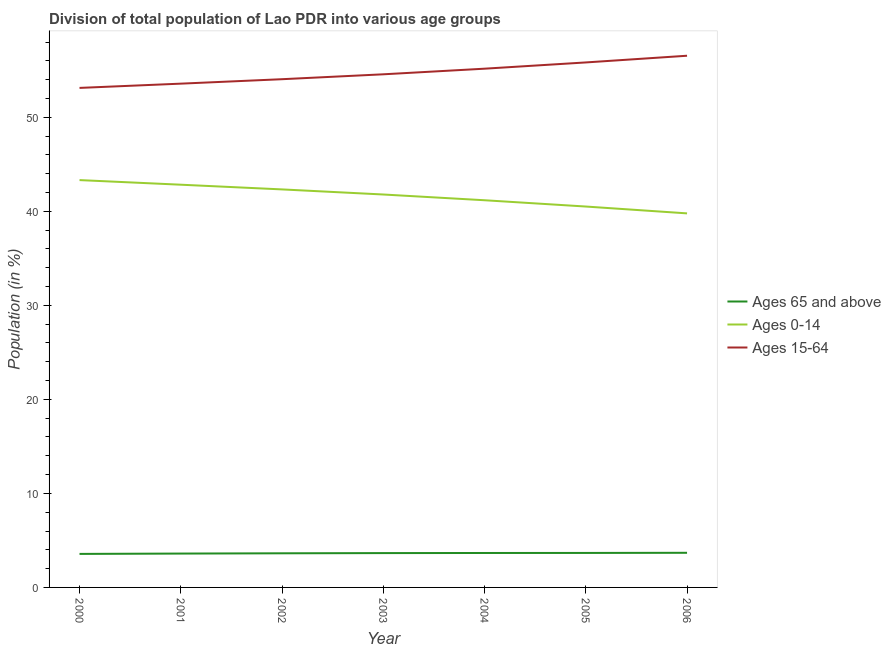What is the percentage of population within the age-group of 65 and above in 2005?
Your response must be concise. 3.67. Across all years, what is the maximum percentage of population within the age-group 0-14?
Your answer should be very brief. 43.32. Across all years, what is the minimum percentage of population within the age-group 0-14?
Provide a succinct answer. 39.78. In which year was the percentage of population within the age-group 0-14 maximum?
Give a very brief answer. 2000. In which year was the percentage of population within the age-group of 65 and above minimum?
Keep it short and to the point. 2000. What is the total percentage of population within the age-group of 65 and above in the graph?
Your response must be concise. 25.46. What is the difference between the percentage of population within the age-group 15-64 in 2000 and that in 2002?
Keep it short and to the point. -0.93. What is the difference between the percentage of population within the age-group of 65 and above in 2004 and the percentage of population within the age-group 15-64 in 2001?
Offer a very short reply. -49.91. What is the average percentage of population within the age-group of 65 and above per year?
Your response must be concise. 3.64. In the year 2001, what is the difference between the percentage of population within the age-group of 65 and above and percentage of population within the age-group 0-14?
Your response must be concise. -39.23. What is the ratio of the percentage of population within the age-group 15-64 in 2002 to that in 2003?
Your answer should be compact. 0.99. Is the difference between the percentage of population within the age-group of 65 and above in 2001 and 2003 greater than the difference between the percentage of population within the age-group 0-14 in 2001 and 2003?
Your response must be concise. No. What is the difference between the highest and the second highest percentage of population within the age-group 15-64?
Provide a succinct answer. 0.71. What is the difference between the highest and the lowest percentage of population within the age-group 15-64?
Your answer should be compact. 3.42. Is the sum of the percentage of population within the age-group 0-14 in 2004 and 2006 greater than the maximum percentage of population within the age-group of 65 and above across all years?
Provide a succinct answer. Yes. Does the percentage of population within the age-group 15-64 monotonically increase over the years?
Ensure brevity in your answer.  Yes. Is the percentage of population within the age-group 0-14 strictly greater than the percentage of population within the age-group 15-64 over the years?
Make the answer very short. No. How many lines are there?
Offer a very short reply. 3. Are the values on the major ticks of Y-axis written in scientific E-notation?
Offer a very short reply. No. Does the graph contain any zero values?
Your response must be concise. No. How many legend labels are there?
Provide a short and direct response. 3. What is the title of the graph?
Provide a short and direct response. Division of total population of Lao PDR into various age groups
. Does "Self-employed" appear as one of the legend labels in the graph?
Ensure brevity in your answer.  No. What is the label or title of the Y-axis?
Give a very brief answer. Population (in %). What is the Population (in %) in Ages 65 and above in 2000?
Offer a terse response. 3.56. What is the Population (in %) of Ages 0-14 in 2000?
Your answer should be compact. 43.32. What is the Population (in %) of Ages 15-64 in 2000?
Your answer should be very brief. 53.12. What is the Population (in %) of Ages 65 and above in 2001?
Give a very brief answer. 3.6. What is the Population (in %) in Ages 0-14 in 2001?
Give a very brief answer. 42.83. What is the Population (in %) of Ages 15-64 in 2001?
Give a very brief answer. 53.57. What is the Population (in %) in Ages 65 and above in 2002?
Provide a succinct answer. 3.63. What is the Population (in %) in Ages 0-14 in 2002?
Offer a very short reply. 42.33. What is the Population (in %) in Ages 15-64 in 2002?
Keep it short and to the point. 54.04. What is the Population (in %) of Ages 65 and above in 2003?
Keep it short and to the point. 3.65. What is the Population (in %) of Ages 0-14 in 2003?
Provide a short and direct response. 41.78. What is the Population (in %) in Ages 15-64 in 2003?
Provide a short and direct response. 54.57. What is the Population (in %) of Ages 65 and above in 2004?
Offer a terse response. 3.66. What is the Population (in %) of Ages 0-14 in 2004?
Make the answer very short. 41.17. What is the Population (in %) of Ages 15-64 in 2004?
Provide a short and direct response. 55.16. What is the Population (in %) in Ages 65 and above in 2005?
Your answer should be very brief. 3.67. What is the Population (in %) in Ages 0-14 in 2005?
Offer a very short reply. 40.5. What is the Population (in %) of Ages 15-64 in 2005?
Your answer should be compact. 55.83. What is the Population (in %) in Ages 65 and above in 2006?
Your response must be concise. 3.68. What is the Population (in %) of Ages 0-14 in 2006?
Your answer should be very brief. 39.78. What is the Population (in %) of Ages 15-64 in 2006?
Make the answer very short. 56.54. Across all years, what is the maximum Population (in %) of Ages 65 and above?
Ensure brevity in your answer.  3.68. Across all years, what is the maximum Population (in %) in Ages 0-14?
Give a very brief answer. 43.32. Across all years, what is the maximum Population (in %) in Ages 15-64?
Provide a short and direct response. 56.54. Across all years, what is the minimum Population (in %) of Ages 65 and above?
Keep it short and to the point. 3.56. Across all years, what is the minimum Population (in %) of Ages 0-14?
Offer a very short reply. 39.78. Across all years, what is the minimum Population (in %) in Ages 15-64?
Your answer should be compact. 53.12. What is the total Population (in %) in Ages 65 and above in the graph?
Provide a short and direct response. 25.46. What is the total Population (in %) of Ages 0-14 in the graph?
Provide a short and direct response. 291.71. What is the total Population (in %) of Ages 15-64 in the graph?
Keep it short and to the point. 382.83. What is the difference between the Population (in %) in Ages 65 and above in 2000 and that in 2001?
Make the answer very short. -0.04. What is the difference between the Population (in %) in Ages 0-14 in 2000 and that in 2001?
Make the answer very short. 0.49. What is the difference between the Population (in %) of Ages 15-64 in 2000 and that in 2001?
Your answer should be very brief. -0.45. What is the difference between the Population (in %) of Ages 65 and above in 2000 and that in 2002?
Your response must be concise. -0.06. What is the difference between the Population (in %) of Ages 15-64 in 2000 and that in 2002?
Make the answer very short. -0.93. What is the difference between the Population (in %) of Ages 65 and above in 2000 and that in 2003?
Your answer should be very brief. -0.09. What is the difference between the Population (in %) of Ages 0-14 in 2000 and that in 2003?
Offer a very short reply. 1.53. What is the difference between the Population (in %) in Ages 15-64 in 2000 and that in 2003?
Make the answer very short. -1.45. What is the difference between the Population (in %) in Ages 65 and above in 2000 and that in 2004?
Offer a terse response. -0.1. What is the difference between the Population (in %) in Ages 0-14 in 2000 and that in 2004?
Offer a terse response. 2.14. What is the difference between the Population (in %) of Ages 15-64 in 2000 and that in 2004?
Your response must be concise. -2.04. What is the difference between the Population (in %) in Ages 65 and above in 2000 and that in 2005?
Provide a short and direct response. -0.1. What is the difference between the Population (in %) of Ages 0-14 in 2000 and that in 2005?
Your answer should be very brief. 2.81. What is the difference between the Population (in %) in Ages 15-64 in 2000 and that in 2005?
Provide a succinct answer. -2.71. What is the difference between the Population (in %) of Ages 65 and above in 2000 and that in 2006?
Provide a succinct answer. -0.12. What is the difference between the Population (in %) in Ages 0-14 in 2000 and that in 2006?
Ensure brevity in your answer.  3.54. What is the difference between the Population (in %) of Ages 15-64 in 2000 and that in 2006?
Make the answer very short. -3.42. What is the difference between the Population (in %) of Ages 65 and above in 2001 and that in 2002?
Provide a short and direct response. -0.03. What is the difference between the Population (in %) in Ages 0-14 in 2001 and that in 2002?
Your answer should be very brief. 0.5. What is the difference between the Population (in %) in Ages 15-64 in 2001 and that in 2002?
Your response must be concise. -0.47. What is the difference between the Population (in %) in Ages 65 and above in 2001 and that in 2003?
Offer a very short reply. -0.05. What is the difference between the Population (in %) of Ages 0-14 in 2001 and that in 2003?
Your response must be concise. 1.04. What is the difference between the Population (in %) in Ages 15-64 in 2001 and that in 2003?
Give a very brief answer. -0.99. What is the difference between the Population (in %) in Ages 65 and above in 2001 and that in 2004?
Make the answer very short. -0.06. What is the difference between the Population (in %) of Ages 0-14 in 2001 and that in 2004?
Offer a terse response. 1.65. What is the difference between the Population (in %) of Ages 15-64 in 2001 and that in 2004?
Offer a terse response. -1.59. What is the difference between the Population (in %) of Ages 65 and above in 2001 and that in 2005?
Give a very brief answer. -0.07. What is the difference between the Population (in %) of Ages 0-14 in 2001 and that in 2005?
Offer a terse response. 2.32. What is the difference between the Population (in %) in Ages 15-64 in 2001 and that in 2005?
Offer a very short reply. -2.26. What is the difference between the Population (in %) in Ages 65 and above in 2001 and that in 2006?
Your answer should be compact. -0.08. What is the difference between the Population (in %) in Ages 0-14 in 2001 and that in 2006?
Ensure brevity in your answer.  3.05. What is the difference between the Population (in %) in Ages 15-64 in 2001 and that in 2006?
Ensure brevity in your answer.  -2.97. What is the difference between the Population (in %) in Ages 65 and above in 2002 and that in 2003?
Your answer should be compact. -0.02. What is the difference between the Population (in %) of Ages 0-14 in 2002 and that in 2003?
Offer a terse response. 0.54. What is the difference between the Population (in %) of Ages 15-64 in 2002 and that in 2003?
Keep it short and to the point. -0.52. What is the difference between the Population (in %) in Ages 65 and above in 2002 and that in 2004?
Keep it short and to the point. -0.03. What is the difference between the Population (in %) in Ages 0-14 in 2002 and that in 2004?
Your answer should be very brief. 1.15. What is the difference between the Population (in %) in Ages 15-64 in 2002 and that in 2004?
Offer a terse response. -1.12. What is the difference between the Population (in %) in Ages 65 and above in 2002 and that in 2005?
Offer a terse response. -0.04. What is the difference between the Population (in %) of Ages 0-14 in 2002 and that in 2005?
Provide a succinct answer. 1.82. What is the difference between the Population (in %) in Ages 15-64 in 2002 and that in 2005?
Make the answer very short. -1.78. What is the difference between the Population (in %) of Ages 65 and above in 2002 and that in 2006?
Your answer should be compact. -0.05. What is the difference between the Population (in %) of Ages 0-14 in 2002 and that in 2006?
Ensure brevity in your answer.  2.55. What is the difference between the Population (in %) in Ages 15-64 in 2002 and that in 2006?
Provide a succinct answer. -2.5. What is the difference between the Population (in %) in Ages 65 and above in 2003 and that in 2004?
Offer a very short reply. -0.01. What is the difference between the Population (in %) of Ages 0-14 in 2003 and that in 2004?
Make the answer very short. 0.61. What is the difference between the Population (in %) in Ages 15-64 in 2003 and that in 2004?
Make the answer very short. -0.6. What is the difference between the Population (in %) in Ages 65 and above in 2003 and that in 2005?
Provide a short and direct response. -0.02. What is the difference between the Population (in %) in Ages 0-14 in 2003 and that in 2005?
Make the answer very short. 1.28. What is the difference between the Population (in %) in Ages 15-64 in 2003 and that in 2005?
Offer a terse response. -1.26. What is the difference between the Population (in %) in Ages 65 and above in 2003 and that in 2006?
Keep it short and to the point. -0.03. What is the difference between the Population (in %) of Ages 0-14 in 2003 and that in 2006?
Your response must be concise. 2.01. What is the difference between the Population (in %) of Ages 15-64 in 2003 and that in 2006?
Offer a very short reply. -1.97. What is the difference between the Population (in %) of Ages 65 and above in 2004 and that in 2005?
Your answer should be compact. -0. What is the difference between the Population (in %) in Ages 0-14 in 2004 and that in 2005?
Ensure brevity in your answer.  0.67. What is the difference between the Population (in %) in Ages 15-64 in 2004 and that in 2005?
Give a very brief answer. -0.66. What is the difference between the Population (in %) of Ages 65 and above in 2004 and that in 2006?
Give a very brief answer. -0.02. What is the difference between the Population (in %) in Ages 0-14 in 2004 and that in 2006?
Provide a succinct answer. 1.4. What is the difference between the Population (in %) in Ages 15-64 in 2004 and that in 2006?
Give a very brief answer. -1.38. What is the difference between the Population (in %) in Ages 65 and above in 2005 and that in 2006?
Provide a succinct answer. -0.01. What is the difference between the Population (in %) of Ages 0-14 in 2005 and that in 2006?
Provide a short and direct response. 0.73. What is the difference between the Population (in %) in Ages 15-64 in 2005 and that in 2006?
Give a very brief answer. -0.71. What is the difference between the Population (in %) in Ages 65 and above in 2000 and the Population (in %) in Ages 0-14 in 2001?
Provide a succinct answer. -39.26. What is the difference between the Population (in %) in Ages 65 and above in 2000 and the Population (in %) in Ages 15-64 in 2001?
Ensure brevity in your answer.  -50.01. What is the difference between the Population (in %) in Ages 0-14 in 2000 and the Population (in %) in Ages 15-64 in 2001?
Keep it short and to the point. -10.26. What is the difference between the Population (in %) in Ages 65 and above in 2000 and the Population (in %) in Ages 0-14 in 2002?
Make the answer very short. -38.76. What is the difference between the Population (in %) in Ages 65 and above in 2000 and the Population (in %) in Ages 15-64 in 2002?
Provide a short and direct response. -50.48. What is the difference between the Population (in %) of Ages 0-14 in 2000 and the Population (in %) of Ages 15-64 in 2002?
Offer a very short reply. -10.73. What is the difference between the Population (in %) of Ages 65 and above in 2000 and the Population (in %) of Ages 0-14 in 2003?
Provide a short and direct response. -38.22. What is the difference between the Population (in %) of Ages 65 and above in 2000 and the Population (in %) of Ages 15-64 in 2003?
Your answer should be compact. -51. What is the difference between the Population (in %) of Ages 0-14 in 2000 and the Population (in %) of Ages 15-64 in 2003?
Keep it short and to the point. -11.25. What is the difference between the Population (in %) in Ages 65 and above in 2000 and the Population (in %) in Ages 0-14 in 2004?
Your answer should be very brief. -37.61. What is the difference between the Population (in %) in Ages 65 and above in 2000 and the Population (in %) in Ages 15-64 in 2004?
Offer a very short reply. -51.6. What is the difference between the Population (in %) of Ages 0-14 in 2000 and the Population (in %) of Ages 15-64 in 2004?
Provide a succinct answer. -11.85. What is the difference between the Population (in %) in Ages 65 and above in 2000 and the Population (in %) in Ages 0-14 in 2005?
Provide a short and direct response. -36.94. What is the difference between the Population (in %) in Ages 65 and above in 2000 and the Population (in %) in Ages 15-64 in 2005?
Your response must be concise. -52.26. What is the difference between the Population (in %) in Ages 0-14 in 2000 and the Population (in %) in Ages 15-64 in 2005?
Your answer should be very brief. -12.51. What is the difference between the Population (in %) of Ages 65 and above in 2000 and the Population (in %) of Ages 0-14 in 2006?
Provide a short and direct response. -36.21. What is the difference between the Population (in %) in Ages 65 and above in 2000 and the Population (in %) in Ages 15-64 in 2006?
Ensure brevity in your answer.  -52.98. What is the difference between the Population (in %) in Ages 0-14 in 2000 and the Population (in %) in Ages 15-64 in 2006?
Your answer should be very brief. -13.22. What is the difference between the Population (in %) of Ages 65 and above in 2001 and the Population (in %) of Ages 0-14 in 2002?
Offer a terse response. -38.72. What is the difference between the Population (in %) in Ages 65 and above in 2001 and the Population (in %) in Ages 15-64 in 2002?
Make the answer very short. -50.44. What is the difference between the Population (in %) in Ages 0-14 in 2001 and the Population (in %) in Ages 15-64 in 2002?
Ensure brevity in your answer.  -11.22. What is the difference between the Population (in %) of Ages 65 and above in 2001 and the Population (in %) of Ages 0-14 in 2003?
Ensure brevity in your answer.  -38.18. What is the difference between the Population (in %) in Ages 65 and above in 2001 and the Population (in %) in Ages 15-64 in 2003?
Keep it short and to the point. -50.96. What is the difference between the Population (in %) in Ages 0-14 in 2001 and the Population (in %) in Ages 15-64 in 2003?
Keep it short and to the point. -11.74. What is the difference between the Population (in %) in Ages 65 and above in 2001 and the Population (in %) in Ages 0-14 in 2004?
Offer a terse response. -37.57. What is the difference between the Population (in %) of Ages 65 and above in 2001 and the Population (in %) of Ages 15-64 in 2004?
Give a very brief answer. -51.56. What is the difference between the Population (in %) in Ages 0-14 in 2001 and the Population (in %) in Ages 15-64 in 2004?
Your response must be concise. -12.34. What is the difference between the Population (in %) in Ages 65 and above in 2001 and the Population (in %) in Ages 0-14 in 2005?
Ensure brevity in your answer.  -36.9. What is the difference between the Population (in %) of Ages 65 and above in 2001 and the Population (in %) of Ages 15-64 in 2005?
Provide a succinct answer. -52.23. What is the difference between the Population (in %) in Ages 0-14 in 2001 and the Population (in %) in Ages 15-64 in 2005?
Make the answer very short. -13. What is the difference between the Population (in %) of Ages 65 and above in 2001 and the Population (in %) of Ages 0-14 in 2006?
Offer a terse response. -36.18. What is the difference between the Population (in %) in Ages 65 and above in 2001 and the Population (in %) in Ages 15-64 in 2006?
Provide a succinct answer. -52.94. What is the difference between the Population (in %) in Ages 0-14 in 2001 and the Population (in %) in Ages 15-64 in 2006?
Provide a succinct answer. -13.71. What is the difference between the Population (in %) of Ages 65 and above in 2002 and the Population (in %) of Ages 0-14 in 2003?
Provide a succinct answer. -38.15. What is the difference between the Population (in %) in Ages 65 and above in 2002 and the Population (in %) in Ages 15-64 in 2003?
Offer a very short reply. -50.94. What is the difference between the Population (in %) of Ages 0-14 in 2002 and the Population (in %) of Ages 15-64 in 2003?
Keep it short and to the point. -12.24. What is the difference between the Population (in %) of Ages 65 and above in 2002 and the Population (in %) of Ages 0-14 in 2004?
Give a very brief answer. -37.54. What is the difference between the Population (in %) of Ages 65 and above in 2002 and the Population (in %) of Ages 15-64 in 2004?
Your response must be concise. -51.53. What is the difference between the Population (in %) in Ages 0-14 in 2002 and the Population (in %) in Ages 15-64 in 2004?
Your answer should be compact. -12.84. What is the difference between the Population (in %) in Ages 65 and above in 2002 and the Population (in %) in Ages 0-14 in 2005?
Give a very brief answer. -36.88. What is the difference between the Population (in %) of Ages 65 and above in 2002 and the Population (in %) of Ages 15-64 in 2005?
Your response must be concise. -52.2. What is the difference between the Population (in %) of Ages 0-14 in 2002 and the Population (in %) of Ages 15-64 in 2005?
Provide a succinct answer. -13.5. What is the difference between the Population (in %) of Ages 65 and above in 2002 and the Population (in %) of Ages 0-14 in 2006?
Your answer should be very brief. -36.15. What is the difference between the Population (in %) in Ages 65 and above in 2002 and the Population (in %) in Ages 15-64 in 2006?
Offer a terse response. -52.91. What is the difference between the Population (in %) of Ages 0-14 in 2002 and the Population (in %) of Ages 15-64 in 2006?
Your answer should be very brief. -14.21. What is the difference between the Population (in %) of Ages 65 and above in 2003 and the Population (in %) of Ages 0-14 in 2004?
Your response must be concise. -37.52. What is the difference between the Population (in %) of Ages 65 and above in 2003 and the Population (in %) of Ages 15-64 in 2004?
Provide a short and direct response. -51.51. What is the difference between the Population (in %) of Ages 0-14 in 2003 and the Population (in %) of Ages 15-64 in 2004?
Your answer should be very brief. -13.38. What is the difference between the Population (in %) in Ages 65 and above in 2003 and the Population (in %) in Ages 0-14 in 2005?
Ensure brevity in your answer.  -36.85. What is the difference between the Population (in %) of Ages 65 and above in 2003 and the Population (in %) of Ages 15-64 in 2005?
Your response must be concise. -52.18. What is the difference between the Population (in %) in Ages 0-14 in 2003 and the Population (in %) in Ages 15-64 in 2005?
Offer a terse response. -14.04. What is the difference between the Population (in %) in Ages 65 and above in 2003 and the Population (in %) in Ages 0-14 in 2006?
Offer a terse response. -36.13. What is the difference between the Population (in %) in Ages 65 and above in 2003 and the Population (in %) in Ages 15-64 in 2006?
Provide a succinct answer. -52.89. What is the difference between the Population (in %) of Ages 0-14 in 2003 and the Population (in %) of Ages 15-64 in 2006?
Your answer should be compact. -14.76. What is the difference between the Population (in %) in Ages 65 and above in 2004 and the Population (in %) in Ages 0-14 in 2005?
Provide a short and direct response. -36.84. What is the difference between the Population (in %) in Ages 65 and above in 2004 and the Population (in %) in Ages 15-64 in 2005?
Keep it short and to the point. -52.16. What is the difference between the Population (in %) in Ages 0-14 in 2004 and the Population (in %) in Ages 15-64 in 2005?
Keep it short and to the point. -14.65. What is the difference between the Population (in %) of Ages 65 and above in 2004 and the Population (in %) of Ages 0-14 in 2006?
Offer a terse response. -36.11. What is the difference between the Population (in %) in Ages 65 and above in 2004 and the Population (in %) in Ages 15-64 in 2006?
Offer a terse response. -52.88. What is the difference between the Population (in %) in Ages 0-14 in 2004 and the Population (in %) in Ages 15-64 in 2006?
Keep it short and to the point. -15.37. What is the difference between the Population (in %) of Ages 65 and above in 2005 and the Population (in %) of Ages 0-14 in 2006?
Give a very brief answer. -36.11. What is the difference between the Population (in %) of Ages 65 and above in 2005 and the Population (in %) of Ages 15-64 in 2006?
Make the answer very short. -52.87. What is the difference between the Population (in %) of Ages 0-14 in 2005 and the Population (in %) of Ages 15-64 in 2006?
Your answer should be very brief. -16.04. What is the average Population (in %) in Ages 65 and above per year?
Your answer should be very brief. 3.64. What is the average Population (in %) in Ages 0-14 per year?
Give a very brief answer. 41.67. What is the average Population (in %) of Ages 15-64 per year?
Your answer should be very brief. 54.69. In the year 2000, what is the difference between the Population (in %) in Ages 65 and above and Population (in %) in Ages 0-14?
Offer a terse response. -39.75. In the year 2000, what is the difference between the Population (in %) of Ages 65 and above and Population (in %) of Ages 15-64?
Your response must be concise. -49.55. In the year 2000, what is the difference between the Population (in %) in Ages 0-14 and Population (in %) in Ages 15-64?
Offer a terse response. -9.8. In the year 2001, what is the difference between the Population (in %) of Ages 65 and above and Population (in %) of Ages 0-14?
Keep it short and to the point. -39.23. In the year 2001, what is the difference between the Population (in %) of Ages 65 and above and Population (in %) of Ages 15-64?
Give a very brief answer. -49.97. In the year 2001, what is the difference between the Population (in %) of Ages 0-14 and Population (in %) of Ages 15-64?
Offer a very short reply. -10.75. In the year 2002, what is the difference between the Population (in %) in Ages 65 and above and Population (in %) in Ages 0-14?
Ensure brevity in your answer.  -38.7. In the year 2002, what is the difference between the Population (in %) in Ages 65 and above and Population (in %) in Ages 15-64?
Your response must be concise. -50.41. In the year 2002, what is the difference between the Population (in %) in Ages 0-14 and Population (in %) in Ages 15-64?
Give a very brief answer. -11.72. In the year 2003, what is the difference between the Population (in %) in Ages 65 and above and Population (in %) in Ages 0-14?
Your answer should be compact. -38.13. In the year 2003, what is the difference between the Population (in %) in Ages 65 and above and Population (in %) in Ages 15-64?
Your answer should be compact. -50.92. In the year 2003, what is the difference between the Population (in %) in Ages 0-14 and Population (in %) in Ages 15-64?
Your response must be concise. -12.78. In the year 2004, what is the difference between the Population (in %) of Ages 65 and above and Population (in %) of Ages 0-14?
Keep it short and to the point. -37.51. In the year 2004, what is the difference between the Population (in %) of Ages 65 and above and Population (in %) of Ages 15-64?
Your answer should be very brief. -51.5. In the year 2004, what is the difference between the Population (in %) of Ages 0-14 and Population (in %) of Ages 15-64?
Your response must be concise. -13.99. In the year 2005, what is the difference between the Population (in %) of Ages 65 and above and Population (in %) of Ages 0-14?
Your answer should be very brief. -36.84. In the year 2005, what is the difference between the Population (in %) in Ages 65 and above and Population (in %) in Ages 15-64?
Your answer should be compact. -52.16. In the year 2005, what is the difference between the Population (in %) of Ages 0-14 and Population (in %) of Ages 15-64?
Provide a succinct answer. -15.32. In the year 2006, what is the difference between the Population (in %) of Ages 65 and above and Population (in %) of Ages 0-14?
Your answer should be compact. -36.09. In the year 2006, what is the difference between the Population (in %) in Ages 65 and above and Population (in %) in Ages 15-64?
Ensure brevity in your answer.  -52.86. In the year 2006, what is the difference between the Population (in %) of Ages 0-14 and Population (in %) of Ages 15-64?
Ensure brevity in your answer.  -16.76. What is the ratio of the Population (in %) of Ages 65 and above in 2000 to that in 2001?
Provide a succinct answer. 0.99. What is the ratio of the Population (in %) in Ages 0-14 in 2000 to that in 2001?
Ensure brevity in your answer.  1.01. What is the ratio of the Population (in %) in Ages 15-64 in 2000 to that in 2001?
Your answer should be compact. 0.99. What is the ratio of the Population (in %) of Ages 65 and above in 2000 to that in 2002?
Offer a very short reply. 0.98. What is the ratio of the Population (in %) in Ages 0-14 in 2000 to that in 2002?
Ensure brevity in your answer.  1.02. What is the ratio of the Population (in %) in Ages 15-64 in 2000 to that in 2002?
Your answer should be very brief. 0.98. What is the ratio of the Population (in %) of Ages 65 and above in 2000 to that in 2003?
Your answer should be compact. 0.98. What is the ratio of the Population (in %) in Ages 0-14 in 2000 to that in 2003?
Provide a short and direct response. 1.04. What is the ratio of the Population (in %) in Ages 15-64 in 2000 to that in 2003?
Provide a succinct answer. 0.97. What is the ratio of the Population (in %) of Ages 65 and above in 2000 to that in 2004?
Make the answer very short. 0.97. What is the ratio of the Population (in %) in Ages 0-14 in 2000 to that in 2004?
Your response must be concise. 1.05. What is the ratio of the Population (in %) of Ages 15-64 in 2000 to that in 2004?
Your answer should be compact. 0.96. What is the ratio of the Population (in %) of Ages 65 and above in 2000 to that in 2005?
Your response must be concise. 0.97. What is the ratio of the Population (in %) in Ages 0-14 in 2000 to that in 2005?
Offer a very short reply. 1.07. What is the ratio of the Population (in %) of Ages 15-64 in 2000 to that in 2005?
Your response must be concise. 0.95. What is the ratio of the Population (in %) of Ages 65 and above in 2000 to that in 2006?
Offer a very short reply. 0.97. What is the ratio of the Population (in %) of Ages 0-14 in 2000 to that in 2006?
Offer a terse response. 1.09. What is the ratio of the Population (in %) of Ages 15-64 in 2000 to that in 2006?
Give a very brief answer. 0.94. What is the ratio of the Population (in %) of Ages 0-14 in 2001 to that in 2002?
Make the answer very short. 1.01. What is the ratio of the Population (in %) of Ages 15-64 in 2001 to that in 2002?
Offer a terse response. 0.99. What is the ratio of the Population (in %) in Ages 65 and above in 2001 to that in 2003?
Provide a short and direct response. 0.99. What is the ratio of the Population (in %) of Ages 0-14 in 2001 to that in 2003?
Keep it short and to the point. 1.02. What is the ratio of the Population (in %) in Ages 15-64 in 2001 to that in 2003?
Your answer should be very brief. 0.98. What is the ratio of the Population (in %) of Ages 65 and above in 2001 to that in 2004?
Offer a very short reply. 0.98. What is the ratio of the Population (in %) in Ages 0-14 in 2001 to that in 2004?
Your answer should be compact. 1.04. What is the ratio of the Population (in %) of Ages 15-64 in 2001 to that in 2004?
Make the answer very short. 0.97. What is the ratio of the Population (in %) in Ages 65 and above in 2001 to that in 2005?
Offer a very short reply. 0.98. What is the ratio of the Population (in %) in Ages 0-14 in 2001 to that in 2005?
Make the answer very short. 1.06. What is the ratio of the Population (in %) of Ages 15-64 in 2001 to that in 2005?
Offer a terse response. 0.96. What is the ratio of the Population (in %) of Ages 65 and above in 2001 to that in 2006?
Your answer should be compact. 0.98. What is the ratio of the Population (in %) in Ages 0-14 in 2001 to that in 2006?
Make the answer very short. 1.08. What is the ratio of the Population (in %) of Ages 15-64 in 2001 to that in 2006?
Your answer should be very brief. 0.95. What is the ratio of the Population (in %) in Ages 65 and above in 2002 to that in 2003?
Keep it short and to the point. 0.99. What is the ratio of the Population (in %) in Ages 0-14 in 2002 to that in 2004?
Offer a terse response. 1.03. What is the ratio of the Population (in %) in Ages 15-64 in 2002 to that in 2004?
Keep it short and to the point. 0.98. What is the ratio of the Population (in %) in Ages 0-14 in 2002 to that in 2005?
Provide a short and direct response. 1.04. What is the ratio of the Population (in %) in Ages 15-64 in 2002 to that in 2005?
Make the answer very short. 0.97. What is the ratio of the Population (in %) in Ages 65 and above in 2002 to that in 2006?
Ensure brevity in your answer.  0.99. What is the ratio of the Population (in %) in Ages 0-14 in 2002 to that in 2006?
Offer a very short reply. 1.06. What is the ratio of the Population (in %) of Ages 15-64 in 2002 to that in 2006?
Your response must be concise. 0.96. What is the ratio of the Population (in %) in Ages 0-14 in 2003 to that in 2004?
Provide a succinct answer. 1.01. What is the ratio of the Population (in %) in Ages 15-64 in 2003 to that in 2004?
Provide a succinct answer. 0.99. What is the ratio of the Population (in %) of Ages 0-14 in 2003 to that in 2005?
Make the answer very short. 1.03. What is the ratio of the Population (in %) of Ages 15-64 in 2003 to that in 2005?
Provide a succinct answer. 0.98. What is the ratio of the Population (in %) of Ages 0-14 in 2003 to that in 2006?
Your answer should be compact. 1.05. What is the ratio of the Population (in %) in Ages 15-64 in 2003 to that in 2006?
Provide a succinct answer. 0.97. What is the ratio of the Population (in %) of Ages 65 and above in 2004 to that in 2005?
Keep it short and to the point. 1. What is the ratio of the Population (in %) in Ages 0-14 in 2004 to that in 2005?
Make the answer very short. 1.02. What is the ratio of the Population (in %) in Ages 15-64 in 2004 to that in 2005?
Provide a succinct answer. 0.99. What is the ratio of the Population (in %) of Ages 65 and above in 2004 to that in 2006?
Provide a succinct answer. 0.99. What is the ratio of the Population (in %) of Ages 0-14 in 2004 to that in 2006?
Provide a succinct answer. 1.04. What is the ratio of the Population (in %) of Ages 15-64 in 2004 to that in 2006?
Provide a succinct answer. 0.98. What is the ratio of the Population (in %) of Ages 65 and above in 2005 to that in 2006?
Offer a very short reply. 1. What is the ratio of the Population (in %) in Ages 0-14 in 2005 to that in 2006?
Offer a terse response. 1.02. What is the ratio of the Population (in %) in Ages 15-64 in 2005 to that in 2006?
Offer a very short reply. 0.99. What is the difference between the highest and the second highest Population (in %) in Ages 65 and above?
Your answer should be compact. 0.01. What is the difference between the highest and the second highest Population (in %) in Ages 0-14?
Make the answer very short. 0.49. What is the difference between the highest and the second highest Population (in %) in Ages 15-64?
Offer a very short reply. 0.71. What is the difference between the highest and the lowest Population (in %) of Ages 65 and above?
Keep it short and to the point. 0.12. What is the difference between the highest and the lowest Population (in %) of Ages 0-14?
Your response must be concise. 3.54. What is the difference between the highest and the lowest Population (in %) in Ages 15-64?
Make the answer very short. 3.42. 